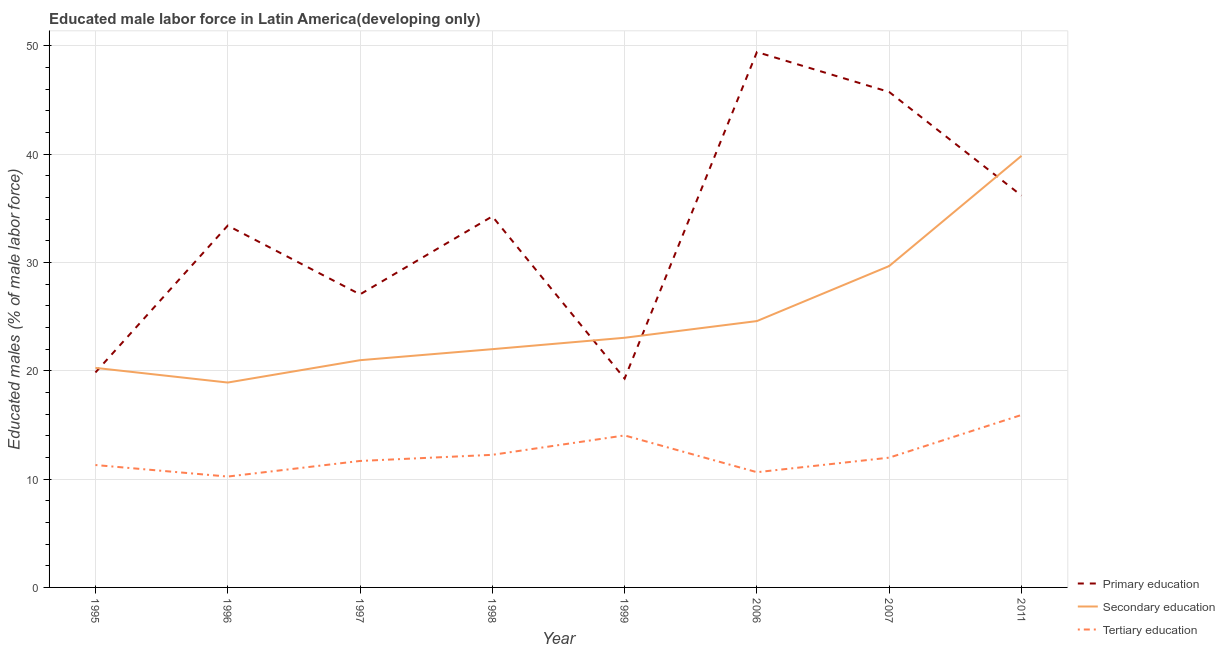How many different coloured lines are there?
Make the answer very short. 3. Does the line corresponding to percentage of male labor force who received secondary education intersect with the line corresponding to percentage of male labor force who received primary education?
Offer a terse response. Yes. What is the percentage of male labor force who received secondary education in 1998?
Offer a terse response. 21.99. Across all years, what is the maximum percentage of male labor force who received tertiary education?
Offer a terse response. 15.92. Across all years, what is the minimum percentage of male labor force who received tertiary education?
Give a very brief answer. 10.23. What is the total percentage of male labor force who received secondary education in the graph?
Make the answer very short. 199.3. What is the difference between the percentage of male labor force who received primary education in 1995 and that in 1997?
Keep it short and to the point. -7.21. What is the difference between the percentage of male labor force who received secondary education in 1999 and the percentage of male labor force who received primary education in 1996?
Your answer should be compact. -10.35. What is the average percentage of male labor force who received tertiary education per year?
Offer a very short reply. 12.25. In the year 2007, what is the difference between the percentage of male labor force who received secondary education and percentage of male labor force who received primary education?
Your response must be concise. -16.06. What is the ratio of the percentage of male labor force who received primary education in 1996 to that in 2011?
Give a very brief answer. 0.92. Is the difference between the percentage of male labor force who received primary education in 1997 and 2006 greater than the difference between the percentage of male labor force who received secondary education in 1997 and 2006?
Your response must be concise. No. What is the difference between the highest and the second highest percentage of male labor force who received primary education?
Your response must be concise. 3.69. What is the difference between the highest and the lowest percentage of male labor force who received secondary education?
Offer a terse response. 20.93. In how many years, is the percentage of male labor force who received primary education greater than the average percentage of male labor force who received primary education taken over all years?
Make the answer very short. 5. Is the percentage of male labor force who received secondary education strictly greater than the percentage of male labor force who received primary education over the years?
Ensure brevity in your answer.  No. Is the percentage of male labor force who received tertiary education strictly less than the percentage of male labor force who received secondary education over the years?
Make the answer very short. Yes. How many years are there in the graph?
Keep it short and to the point. 8. What is the difference between two consecutive major ticks on the Y-axis?
Provide a succinct answer. 10. Are the values on the major ticks of Y-axis written in scientific E-notation?
Provide a short and direct response. No. Does the graph contain any zero values?
Ensure brevity in your answer.  No. Does the graph contain grids?
Ensure brevity in your answer.  Yes. What is the title of the graph?
Make the answer very short. Educated male labor force in Latin America(developing only). Does "Interest" appear as one of the legend labels in the graph?
Provide a short and direct response. No. What is the label or title of the X-axis?
Give a very brief answer. Year. What is the label or title of the Y-axis?
Your response must be concise. Educated males (% of male labor force). What is the Educated males (% of male labor force) in Primary education in 1995?
Ensure brevity in your answer.  19.84. What is the Educated males (% of male labor force) of Secondary education in 1995?
Ensure brevity in your answer.  20.27. What is the Educated males (% of male labor force) of Tertiary education in 1995?
Give a very brief answer. 11.3. What is the Educated males (% of male labor force) in Primary education in 1996?
Ensure brevity in your answer.  33.4. What is the Educated males (% of male labor force) in Secondary education in 1996?
Your answer should be very brief. 18.91. What is the Educated males (% of male labor force) in Tertiary education in 1996?
Your answer should be very brief. 10.23. What is the Educated males (% of male labor force) in Primary education in 1997?
Offer a very short reply. 27.05. What is the Educated males (% of male labor force) in Secondary education in 1997?
Provide a succinct answer. 20.98. What is the Educated males (% of male labor force) of Tertiary education in 1997?
Make the answer very short. 11.67. What is the Educated males (% of male labor force) of Primary education in 1998?
Ensure brevity in your answer.  34.25. What is the Educated males (% of male labor force) of Secondary education in 1998?
Make the answer very short. 21.99. What is the Educated males (% of male labor force) in Tertiary education in 1998?
Give a very brief answer. 12.24. What is the Educated males (% of male labor force) in Primary education in 1999?
Your answer should be very brief. 19.28. What is the Educated males (% of male labor force) of Secondary education in 1999?
Keep it short and to the point. 23.05. What is the Educated males (% of male labor force) in Tertiary education in 1999?
Ensure brevity in your answer.  14.03. What is the Educated males (% of male labor force) in Primary education in 2006?
Your response must be concise. 49.42. What is the Educated males (% of male labor force) of Secondary education in 2006?
Give a very brief answer. 24.59. What is the Educated males (% of male labor force) in Tertiary education in 2006?
Make the answer very short. 10.64. What is the Educated males (% of male labor force) in Primary education in 2007?
Your response must be concise. 45.73. What is the Educated males (% of male labor force) of Secondary education in 2007?
Your response must be concise. 29.67. What is the Educated males (% of male labor force) in Tertiary education in 2007?
Keep it short and to the point. 11.98. What is the Educated males (% of male labor force) of Primary education in 2011?
Your answer should be very brief. 36.17. What is the Educated males (% of male labor force) of Secondary education in 2011?
Provide a short and direct response. 39.84. What is the Educated males (% of male labor force) in Tertiary education in 2011?
Keep it short and to the point. 15.92. Across all years, what is the maximum Educated males (% of male labor force) in Primary education?
Give a very brief answer. 49.42. Across all years, what is the maximum Educated males (% of male labor force) in Secondary education?
Offer a terse response. 39.84. Across all years, what is the maximum Educated males (% of male labor force) in Tertiary education?
Keep it short and to the point. 15.92. Across all years, what is the minimum Educated males (% of male labor force) in Primary education?
Your answer should be compact. 19.28. Across all years, what is the minimum Educated males (% of male labor force) in Secondary education?
Ensure brevity in your answer.  18.91. Across all years, what is the minimum Educated males (% of male labor force) of Tertiary education?
Provide a short and direct response. 10.23. What is the total Educated males (% of male labor force) in Primary education in the graph?
Give a very brief answer. 265.16. What is the total Educated males (% of male labor force) of Secondary education in the graph?
Provide a short and direct response. 199.3. What is the total Educated males (% of male labor force) of Tertiary education in the graph?
Provide a short and direct response. 98.02. What is the difference between the Educated males (% of male labor force) of Primary education in 1995 and that in 1996?
Offer a very short reply. -13.56. What is the difference between the Educated males (% of male labor force) of Secondary education in 1995 and that in 1996?
Make the answer very short. 1.35. What is the difference between the Educated males (% of male labor force) of Tertiary education in 1995 and that in 1996?
Give a very brief answer. 1.06. What is the difference between the Educated males (% of male labor force) of Primary education in 1995 and that in 1997?
Ensure brevity in your answer.  -7.21. What is the difference between the Educated males (% of male labor force) in Secondary education in 1995 and that in 1997?
Provide a short and direct response. -0.71. What is the difference between the Educated males (% of male labor force) in Tertiary education in 1995 and that in 1997?
Your answer should be very brief. -0.37. What is the difference between the Educated males (% of male labor force) in Primary education in 1995 and that in 1998?
Your response must be concise. -14.41. What is the difference between the Educated males (% of male labor force) of Secondary education in 1995 and that in 1998?
Make the answer very short. -1.73. What is the difference between the Educated males (% of male labor force) in Tertiary education in 1995 and that in 1998?
Make the answer very short. -0.94. What is the difference between the Educated males (% of male labor force) in Primary education in 1995 and that in 1999?
Ensure brevity in your answer.  0.57. What is the difference between the Educated males (% of male labor force) in Secondary education in 1995 and that in 1999?
Ensure brevity in your answer.  -2.78. What is the difference between the Educated males (% of male labor force) in Tertiary education in 1995 and that in 1999?
Make the answer very short. -2.73. What is the difference between the Educated males (% of male labor force) of Primary education in 1995 and that in 2006?
Make the answer very short. -29.58. What is the difference between the Educated males (% of male labor force) of Secondary education in 1995 and that in 2006?
Provide a short and direct response. -4.32. What is the difference between the Educated males (% of male labor force) of Tertiary education in 1995 and that in 2006?
Your response must be concise. 0.66. What is the difference between the Educated males (% of male labor force) of Primary education in 1995 and that in 2007?
Ensure brevity in your answer.  -25.89. What is the difference between the Educated males (% of male labor force) of Secondary education in 1995 and that in 2007?
Give a very brief answer. -9.4. What is the difference between the Educated males (% of male labor force) in Tertiary education in 1995 and that in 2007?
Provide a short and direct response. -0.68. What is the difference between the Educated males (% of male labor force) in Primary education in 1995 and that in 2011?
Provide a succinct answer. -16.33. What is the difference between the Educated males (% of male labor force) of Secondary education in 1995 and that in 2011?
Keep it short and to the point. -19.58. What is the difference between the Educated males (% of male labor force) in Tertiary education in 1995 and that in 2011?
Your answer should be very brief. -4.62. What is the difference between the Educated males (% of male labor force) in Primary education in 1996 and that in 1997?
Ensure brevity in your answer.  6.35. What is the difference between the Educated males (% of male labor force) of Secondary education in 1996 and that in 1997?
Your response must be concise. -2.06. What is the difference between the Educated males (% of male labor force) in Tertiary education in 1996 and that in 1997?
Ensure brevity in your answer.  -1.44. What is the difference between the Educated males (% of male labor force) in Primary education in 1996 and that in 1998?
Offer a very short reply. -0.85. What is the difference between the Educated males (% of male labor force) in Secondary education in 1996 and that in 1998?
Offer a very short reply. -3.08. What is the difference between the Educated males (% of male labor force) in Tertiary education in 1996 and that in 1998?
Your answer should be compact. -2.01. What is the difference between the Educated males (% of male labor force) of Primary education in 1996 and that in 1999?
Your response must be concise. 14.12. What is the difference between the Educated males (% of male labor force) of Secondary education in 1996 and that in 1999?
Offer a very short reply. -4.13. What is the difference between the Educated males (% of male labor force) in Tertiary education in 1996 and that in 1999?
Give a very brief answer. -3.8. What is the difference between the Educated males (% of male labor force) in Primary education in 1996 and that in 2006?
Offer a terse response. -16.02. What is the difference between the Educated males (% of male labor force) of Secondary education in 1996 and that in 2006?
Your response must be concise. -5.67. What is the difference between the Educated males (% of male labor force) of Tertiary education in 1996 and that in 2006?
Your answer should be compact. -0.4. What is the difference between the Educated males (% of male labor force) of Primary education in 1996 and that in 2007?
Your response must be concise. -12.33. What is the difference between the Educated males (% of male labor force) in Secondary education in 1996 and that in 2007?
Offer a terse response. -10.76. What is the difference between the Educated males (% of male labor force) in Tertiary education in 1996 and that in 2007?
Your response must be concise. -1.74. What is the difference between the Educated males (% of male labor force) of Primary education in 1996 and that in 2011?
Provide a short and direct response. -2.77. What is the difference between the Educated males (% of male labor force) in Secondary education in 1996 and that in 2011?
Offer a terse response. -20.93. What is the difference between the Educated males (% of male labor force) in Tertiary education in 1996 and that in 2011?
Offer a very short reply. -5.69. What is the difference between the Educated males (% of male labor force) in Primary education in 1997 and that in 1998?
Provide a short and direct response. -7.2. What is the difference between the Educated males (% of male labor force) in Secondary education in 1997 and that in 1998?
Provide a succinct answer. -1.02. What is the difference between the Educated males (% of male labor force) of Tertiary education in 1997 and that in 1998?
Provide a short and direct response. -0.57. What is the difference between the Educated males (% of male labor force) in Primary education in 1997 and that in 1999?
Provide a short and direct response. 7.77. What is the difference between the Educated males (% of male labor force) of Secondary education in 1997 and that in 1999?
Keep it short and to the point. -2.07. What is the difference between the Educated males (% of male labor force) in Tertiary education in 1997 and that in 1999?
Your response must be concise. -2.36. What is the difference between the Educated males (% of male labor force) in Primary education in 1997 and that in 2006?
Provide a succinct answer. -22.37. What is the difference between the Educated males (% of male labor force) of Secondary education in 1997 and that in 2006?
Your answer should be very brief. -3.61. What is the difference between the Educated males (% of male labor force) in Tertiary education in 1997 and that in 2006?
Keep it short and to the point. 1.04. What is the difference between the Educated males (% of male labor force) in Primary education in 1997 and that in 2007?
Offer a terse response. -18.68. What is the difference between the Educated males (% of male labor force) of Secondary education in 1997 and that in 2007?
Keep it short and to the point. -8.69. What is the difference between the Educated males (% of male labor force) of Tertiary education in 1997 and that in 2007?
Provide a short and direct response. -0.31. What is the difference between the Educated males (% of male labor force) of Primary education in 1997 and that in 2011?
Ensure brevity in your answer.  -9.12. What is the difference between the Educated males (% of male labor force) of Secondary education in 1997 and that in 2011?
Make the answer very short. -18.87. What is the difference between the Educated males (% of male labor force) of Tertiary education in 1997 and that in 2011?
Your response must be concise. -4.25. What is the difference between the Educated males (% of male labor force) of Primary education in 1998 and that in 1999?
Offer a very short reply. 14.97. What is the difference between the Educated males (% of male labor force) in Secondary education in 1998 and that in 1999?
Make the answer very short. -1.05. What is the difference between the Educated males (% of male labor force) in Tertiary education in 1998 and that in 1999?
Offer a very short reply. -1.79. What is the difference between the Educated males (% of male labor force) of Primary education in 1998 and that in 2006?
Keep it short and to the point. -15.17. What is the difference between the Educated males (% of male labor force) in Secondary education in 1998 and that in 2006?
Offer a very short reply. -2.59. What is the difference between the Educated males (% of male labor force) of Tertiary education in 1998 and that in 2006?
Offer a terse response. 1.6. What is the difference between the Educated males (% of male labor force) in Primary education in 1998 and that in 2007?
Provide a short and direct response. -11.48. What is the difference between the Educated males (% of male labor force) of Secondary education in 1998 and that in 2007?
Keep it short and to the point. -7.68. What is the difference between the Educated males (% of male labor force) in Tertiary education in 1998 and that in 2007?
Give a very brief answer. 0.26. What is the difference between the Educated males (% of male labor force) of Primary education in 1998 and that in 2011?
Keep it short and to the point. -1.92. What is the difference between the Educated males (% of male labor force) in Secondary education in 1998 and that in 2011?
Your answer should be very brief. -17.85. What is the difference between the Educated males (% of male labor force) of Tertiary education in 1998 and that in 2011?
Your response must be concise. -3.68. What is the difference between the Educated males (% of male labor force) in Primary education in 1999 and that in 2006?
Offer a very short reply. -30.14. What is the difference between the Educated males (% of male labor force) in Secondary education in 1999 and that in 2006?
Offer a terse response. -1.54. What is the difference between the Educated males (% of male labor force) of Tertiary education in 1999 and that in 2006?
Give a very brief answer. 3.39. What is the difference between the Educated males (% of male labor force) in Primary education in 1999 and that in 2007?
Provide a succinct answer. -26.46. What is the difference between the Educated males (% of male labor force) of Secondary education in 1999 and that in 2007?
Your response must be concise. -6.62. What is the difference between the Educated males (% of male labor force) of Tertiary education in 1999 and that in 2007?
Offer a very short reply. 2.05. What is the difference between the Educated males (% of male labor force) of Primary education in 1999 and that in 2011?
Give a very brief answer. -16.89. What is the difference between the Educated males (% of male labor force) in Secondary education in 1999 and that in 2011?
Offer a very short reply. -16.8. What is the difference between the Educated males (% of male labor force) in Tertiary education in 1999 and that in 2011?
Provide a succinct answer. -1.89. What is the difference between the Educated males (% of male labor force) of Primary education in 2006 and that in 2007?
Offer a very short reply. 3.69. What is the difference between the Educated males (% of male labor force) of Secondary education in 2006 and that in 2007?
Keep it short and to the point. -5.08. What is the difference between the Educated males (% of male labor force) of Tertiary education in 2006 and that in 2007?
Provide a succinct answer. -1.34. What is the difference between the Educated males (% of male labor force) of Primary education in 2006 and that in 2011?
Ensure brevity in your answer.  13.25. What is the difference between the Educated males (% of male labor force) of Secondary education in 2006 and that in 2011?
Keep it short and to the point. -15.25. What is the difference between the Educated males (% of male labor force) in Tertiary education in 2006 and that in 2011?
Offer a terse response. -5.28. What is the difference between the Educated males (% of male labor force) in Primary education in 2007 and that in 2011?
Ensure brevity in your answer.  9.56. What is the difference between the Educated males (% of male labor force) of Secondary education in 2007 and that in 2011?
Keep it short and to the point. -10.17. What is the difference between the Educated males (% of male labor force) of Tertiary education in 2007 and that in 2011?
Ensure brevity in your answer.  -3.94. What is the difference between the Educated males (% of male labor force) of Primary education in 1995 and the Educated males (% of male labor force) of Secondary education in 1996?
Make the answer very short. 0.93. What is the difference between the Educated males (% of male labor force) of Primary education in 1995 and the Educated males (% of male labor force) of Tertiary education in 1996?
Give a very brief answer. 9.61. What is the difference between the Educated males (% of male labor force) of Secondary education in 1995 and the Educated males (% of male labor force) of Tertiary education in 1996?
Make the answer very short. 10.03. What is the difference between the Educated males (% of male labor force) of Primary education in 1995 and the Educated males (% of male labor force) of Secondary education in 1997?
Keep it short and to the point. -1.13. What is the difference between the Educated males (% of male labor force) in Primary education in 1995 and the Educated males (% of male labor force) in Tertiary education in 1997?
Keep it short and to the point. 8.17. What is the difference between the Educated males (% of male labor force) in Secondary education in 1995 and the Educated males (% of male labor force) in Tertiary education in 1997?
Your answer should be compact. 8.59. What is the difference between the Educated males (% of male labor force) in Primary education in 1995 and the Educated males (% of male labor force) in Secondary education in 1998?
Provide a short and direct response. -2.15. What is the difference between the Educated males (% of male labor force) of Primary education in 1995 and the Educated males (% of male labor force) of Tertiary education in 1998?
Offer a very short reply. 7.6. What is the difference between the Educated males (% of male labor force) of Secondary education in 1995 and the Educated males (% of male labor force) of Tertiary education in 1998?
Your answer should be very brief. 8.03. What is the difference between the Educated males (% of male labor force) of Primary education in 1995 and the Educated males (% of male labor force) of Secondary education in 1999?
Keep it short and to the point. -3.2. What is the difference between the Educated males (% of male labor force) of Primary education in 1995 and the Educated males (% of male labor force) of Tertiary education in 1999?
Give a very brief answer. 5.81. What is the difference between the Educated males (% of male labor force) of Secondary education in 1995 and the Educated males (% of male labor force) of Tertiary education in 1999?
Your response must be concise. 6.24. What is the difference between the Educated males (% of male labor force) in Primary education in 1995 and the Educated males (% of male labor force) in Secondary education in 2006?
Provide a short and direct response. -4.74. What is the difference between the Educated males (% of male labor force) of Primary education in 1995 and the Educated males (% of male labor force) of Tertiary education in 2006?
Your response must be concise. 9.21. What is the difference between the Educated males (% of male labor force) in Secondary education in 1995 and the Educated males (% of male labor force) in Tertiary education in 2006?
Your answer should be compact. 9.63. What is the difference between the Educated males (% of male labor force) of Primary education in 1995 and the Educated males (% of male labor force) of Secondary education in 2007?
Ensure brevity in your answer.  -9.82. What is the difference between the Educated males (% of male labor force) in Primary education in 1995 and the Educated males (% of male labor force) in Tertiary education in 2007?
Your answer should be very brief. 7.87. What is the difference between the Educated males (% of male labor force) in Secondary education in 1995 and the Educated males (% of male labor force) in Tertiary education in 2007?
Your response must be concise. 8.29. What is the difference between the Educated males (% of male labor force) of Primary education in 1995 and the Educated males (% of male labor force) of Secondary education in 2011?
Keep it short and to the point. -20. What is the difference between the Educated males (% of male labor force) in Primary education in 1995 and the Educated males (% of male labor force) in Tertiary education in 2011?
Provide a short and direct response. 3.92. What is the difference between the Educated males (% of male labor force) in Secondary education in 1995 and the Educated males (% of male labor force) in Tertiary education in 2011?
Make the answer very short. 4.35. What is the difference between the Educated males (% of male labor force) in Primary education in 1996 and the Educated males (% of male labor force) in Secondary education in 1997?
Keep it short and to the point. 12.42. What is the difference between the Educated males (% of male labor force) in Primary education in 1996 and the Educated males (% of male labor force) in Tertiary education in 1997?
Offer a terse response. 21.73. What is the difference between the Educated males (% of male labor force) in Secondary education in 1996 and the Educated males (% of male labor force) in Tertiary education in 1997?
Provide a short and direct response. 7.24. What is the difference between the Educated males (% of male labor force) of Primary education in 1996 and the Educated males (% of male labor force) of Secondary education in 1998?
Offer a terse response. 11.41. What is the difference between the Educated males (% of male labor force) in Primary education in 1996 and the Educated males (% of male labor force) in Tertiary education in 1998?
Offer a terse response. 21.16. What is the difference between the Educated males (% of male labor force) in Secondary education in 1996 and the Educated males (% of male labor force) in Tertiary education in 1998?
Offer a very short reply. 6.67. What is the difference between the Educated males (% of male labor force) in Primary education in 1996 and the Educated males (% of male labor force) in Secondary education in 1999?
Your answer should be compact. 10.35. What is the difference between the Educated males (% of male labor force) of Primary education in 1996 and the Educated males (% of male labor force) of Tertiary education in 1999?
Give a very brief answer. 19.37. What is the difference between the Educated males (% of male labor force) in Secondary education in 1996 and the Educated males (% of male labor force) in Tertiary education in 1999?
Your answer should be very brief. 4.88. What is the difference between the Educated males (% of male labor force) of Primary education in 1996 and the Educated males (% of male labor force) of Secondary education in 2006?
Your response must be concise. 8.81. What is the difference between the Educated males (% of male labor force) of Primary education in 1996 and the Educated males (% of male labor force) of Tertiary education in 2006?
Your answer should be compact. 22.76. What is the difference between the Educated males (% of male labor force) in Secondary education in 1996 and the Educated males (% of male labor force) in Tertiary education in 2006?
Offer a very short reply. 8.28. What is the difference between the Educated males (% of male labor force) of Primary education in 1996 and the Educated males (% of male labor force) of Secondary education in 2007?
Your answer should be very brief. 3.73. What is the difference between the Educated males (% of male labor force) in Primary education in 1996 and the Educated males (% of male labor force) in Tertiary education in 2007?
Your answer should be very brief. 21.42. What is the difference between the Educated males (% of male labor force) in Secondary education in 1996 and the Educated males (% of male labor force) in Tertiary education in 2007?
Your response must be concise. 6.93. What is the difference between the Educated males (% of male labor force) in Primary education in 1996 and the Educated males (% of male labor force) in Secondary education in 2011?
Ensure brevity in your answer.  -6.44. What is the difference between the Educated males (% of male labor force) of Primary education in 1996 and the Educated males (% of male labor force) of Tertiary education in 2011?
Keep it short and to the point. 17.48. What is the difference between the Educated males (% of male labor force) in Secondary education in 1996 and the Educated males (% of male labor force) in Tertiary education in 2011?
Offer a terse response. 2.99. What is the difference between the Educated males (% of male labor force) of Primary education in 1997 and the Educated males (% of male labor force) of Secondary education in 1998?
Your answer should be very brief. 5.06. What is the difference between the Educated males (% of male labor force) in Primary education in 1997 and the Educated males (% of male labor force) in Tertiary education in 1998?
Your answer should be very brief. 14.81. What is the difference between the Educated males (% of male labor force) of Secondary education in 1997 and the Educated males (% of male labor force) of Tertiary education in 1998?
Give a very brief answer. 8.74. What is the difference between the Educated males (% of male labor force) of Primary education in 1997 and the Educated males (% of male labor force) of Secondary education in 1999?
Give a very brief answer. 4.01. What is the difference between the Educated males (% of male labor force) in Primary education in 1997 and the Educated males (% of male labor force) in Tertiary education in 1999?
Your response must be concise. 13.02. What is the difference between the Educated males (% of male labor force) of Secondary education in 1997 and the Educated males (% of male labor force) of Tertiary education in 1999?
Give a very brief answer. 6.95. What is the difference between the Educated males (% of male labor force) of Primary education in 1997 and the Educated males (% of male labor force) of Secondary education in 2006?
Your response must be concise. 2.46. What is the difference between the Educated males (% of male labor force) of Primary education in 1997 and the Educated males (% of male labor force) of Tertiary education in 2006?
Offer a terse response. 16.42. What is the difference between the Educated males (% of male labor force) of Secondary education in 1997 and the Educated males (% of male labor force) of Tertiary education in 2006?
Provide a succinct answer. 10.34. What is the difference between the Educated males (% of male labor force) of Primary education in 1997 and the Educated males (% of male labor force) of Secondary education in 2007?
Offer a terse response. -2.62. What is the difference between the Educated males (% of male labor force) in Primary education in 1997 and the Educated males (% of male labor force) in Tertiary education in 2007?
Your response must be concise. 15.07. What is the difference between the Educated males (% of male labor force) of Secondary education in 1997 and the Educated males (% of male labor force) of Tertiary education in 2007?
Your response must be concise. 9. What is the difference between the Educated males (% of male labor force) in Primary education in 1997 and the Educated males (% of male labor force) in Secondary education in 2011?
Provide a succinct answer. -12.79. What is the difference between the Educated males (% of male labor force) of Primary education in 1997 and the Educated males (% of male labor force) of Tertiary education in 2011?
Your response must be concise. 11.13. What is the difference between the Educated males (% of male labor force) in Secondary education in 1997 and the Educated males (% of male labor force) in Tertiary education in 2011?
Your answer should be very brief. 5.05. What is the difference between the Educated males (% of male labor force) in Primary education in 1998 and the Educated males (% of male labor force) in Secondary education in 1999?
Ensure brevity in your answer.  11.21. What is the difference between the Educated males (% of male labor force) in Primary education in 1998 and the Educated males (% of male labor force) in Tertiary education in 1999?
Ensure brevity in your answer.  20.22. What is the difference between the Educated males (% of male labor force) in Secondary education in 1998 and the Educated males (% of male labor force) in Tertiary education in 1999?
Keep it short and to the point. 7.96. What is the difference between the Educated males (% of male labor force) of Primary education in 1998 and the Educated males (% of male labor force) of Secondary education in 2006?
Provide a short and direct response. 9.67. What is the difference between the Educated males (% of male labor force) of Primary education in 1998 and the Educated males (% of male labor force) of Tertiary education in 2006?
Ensure brevity in your answer.  23.62. What is the difference between the Educated males (% of male labor force) in Secondary education in 1998 and the Educated males (% of male labor force) in Tertiary education in 2006?
Give a very brief answer. 11.36. What is the difference between the Educated males (% of male labor force) of Primary education in 1998 and the Educated males (% of male labor force) of Secondary education in 2007?
Your response must be concise. 4.58. What is the difference between the Educated males (% of male labor force) of Primary education in 1998 and the Educated males (% of male labor force) of Tertiary education in 2007?
Provide a succinct answer. 22.27. What is the difference between the Educated males (% of male labor force) in Secondary education in 1998 and the Educated males (% of male labor force) in Tertiary education in 2007?
Make the answer very short. 10.01. What is the difference between the Educated males (% of male labor force) in Primary education in 1998 and the Educated males (% of male labor force) in Secondary education in 2011?
Your response must be concise. -5.59. What is the difference between the Educated males (% of male labor force) of Primary education in 1998 and the Educated males (% of male labor force) of Tertiary education in 2011?
Give a very brief answer. 18.33. What is the difference between the Educated males (% of male labor force) of Secondary education in 1998 and the Educated males (% of male labor force) of Tertiary education in 2011?
Your response must be concise. 6.07. What is the difference between the Educated males (% of male labor force) in Primary education in 1999 and the Educated males (% of male labor force) in Secondary education in 2006?
Provide a succinct answer. -5.31. What is the difference between the Educated males (% of male labor force) in Primary education in 1999 and the Educated males (% of male labor force) in Tertiary education in 2006?
Your response must be concise. 8.64. What is the difference between the Educated males (% of male labor force) of Secondary education in 1999 and the Educated males (% of male labor force) of Tertiary education in 2006?
Offer a very short reply. 12.41. What is the difference between the Educated males (% of male labor force) in Primary education in 1999 and the Educated males (% of male labor force) in Secondary education in 2007?
Your response must be concise. -10.39. What is the difference between the Educated males (% of male labor force) in Primary education in 1999 and the Educated males (% of male labor force) in Tertiary education in 2007?
Ensure brevity in your answer.  7.3. What is the difference between the Educated males (% of male labor force) in Secondary education in 1999 and the Educated males (% of male labor force) in Tertiary education in 2007?
Provide a short and direct response. 11.07. What is the difference between the Educated males (% of male labor force) in Primary education in 1999 and the Educated males (% of male labor force) in Secondary education in 2011?
Provide a succinct answer. -20.56. What is the difference between the Educated males (% of male labor force) in Primary education in 1999 and the Educated males (% of male labor force) in Tertiary education in 2011?
Offer a very short reply. 3.36. What is the difference between the Educated males (% of male labor force) in Secondary education in 1999 and the Educated males (% of male labor force) in Tertiary education in 2011?
Ensure brevity in your answer.  7.13. What is the difference between the Educated males (% of male labor force) in Primary education in 2006 and the Educated males (% of male labor force) in Secondary education in 2007?
Your response must be concise. 19.75. What is the difference between the Educated males (% of male labor force) in Primary education in 2006 and the Educated males (% of male labor force) in Tertiary education in 2007?
Provide a short and direct response. 37.44. What is the difference between the Educated males (% of male labor force) in Secondary education in 2006 and the Educated males (% of male labor force) in Tertiary education in 2007?
Your answer should be compact. 12.61. What is the difference between the Educated males (% of male labor force) in Primary education in 2006 and the Educated males (% of male labor force) in Secondary education in 2011?
Your response must be concise. 9.58. What is the difference between the Educated males (% of male labor force) of Primary education in 2006 and the Educated males (% of male labor force) of Tertiary education in 2011?
Provide a succinct answer. 33.5. What is the difference between the Educated males (% of male labor force) of Secondary education in 2006 and the Educated males (% of male labor force) of Tertiary education in 2011?
Keep it short and to the point. 8.67. What is the difference between the Educated males (% of male labor force) of Primary education in 2007 and the Educated males (% of male labor force) of Secondary education in 2011?
Offer a very short reply. 5.89. What is the difference between the Educated males (% of male labor force) in Primary education in 2007 and the Educated males (% of male labor force) in Tertiary education in 2011?
Provide a succinct answer. 29.81. What is the difference between the Educated males (% of male labor force) of Secondary education in 2007 and the Educated males (% of male labor force) of Tertiary education in 2011?
Your answer should be compact. 13.75. What is the average Educated males (% of male labor force) in Primary education per year?
Ensure brevity in your answer.  33.14. What is the average Educated males (% of male labor force) of Secondary education per year?
Provide a short and direct response. 24.91. What is the average Educated males (% of male labor force) in Tertiary education per year?
Give a very brief answer. 12.25. In the year 1995, what is the difference between the Educated males (% of male labor force) of Primary education and Educated males (% of male labor force) of Secondary education?
Keep it short and to the point. -0.42. In the year 1995, what is the difference between the Educated males (% of male labor force) in Primary education and Educated males (% of male labor force) in Tertiary education?
Give a very brief answer. 8.55. In the year 1995, what is the difference between the Educated males (% of male labor force) of Secondary education and Educated males (% of male labor force) of Tertiary education?
Keep it short and to the point. 8.97. In the year 1996, what is the difference between the Educated males (% of male labor force) of Primary education and Educated males (% of male labor force) of Secondary education?
Give a very brief answer. 14.49. In the year 1996, what is the difference between the Educated males (% of male labor force) of Primary education and Educated males (% of male labor force) of Tertiary education?
Your answer should be compact. 23.17. In the year 1996, what is the difference between the Educated males (% of male labor force) of Secondary education and Educated males (% of male labor force) of Tertiary education?
Provide a short and direct response. 8.68. In the year 1997, what is the difference between the Educated males (% of male labor force) in Primary education and Educated males (% of male labor force) in Secondary education?
Offer a very short reply. 6.08. In the year 1997, what is the difference between the Educated males (% of male labor force) in Primary education and Educated males (% of male labor force) in Tertiary education?
Your response must be concise. 15.38. In the year 1997, what is the difference between the Educated males (% of male labor force) in Secondary education and Educated males (% of male labor force) in Tertiary education?
Make the answer very short. 9.3. In the year 1998, what is the difference between the Educated males (% of male labor force) of Primary education and Educated males (% of male labor force) of Secondary education?
Offer a very short reply. 12.26. In the year 1998, what is the difference between the Educated males (% of male labor force) in Primary education and Educated males (% of male labor force) in Tertiary education?
Offer a terse response. 22.01. In the year 1998, what is the difference between the Educated males (% of male labor force) of Secondary education and Educated males (% of male labor force) of Tertiary education?
Offer a terse response. 9.75. In the year 1999, what is the difference between the Educated males (% of male labor force) in Primary education and Educated males (% of male labor force) in Secondary education?
Your answer should be very brief. -3.77. In the year 1999, what is the difference between the Educated males (% of male labor force) of Primary education and Educated males (% of male labor force) of Tertiary education?
Provide a succinct answer. 5.25. In the year 1999, what is the difference between the Educated males (% of male labor force) in Secondary education and Educated males (% of male labor force) in Tertiary education?
Provide a short and direct response. 9.02. In the year 2006, what is the difference between the Educated males (% of male labor force) in Primary education and Educated males (% of male labor force) in Secondary education?
Your answer should be compact. 24.83. In the year 2006, what is the difference between the Educated males (% of male labor force) of Primary education and Educated males (% of male labor force) of Tertiary education?
Your answer should be compact. 38.79. In the year 2006, what is the difference between the Educated males (% of male labor force) of Secondary education and Educated males (% of male labor force) of Tertiary education?
Your answer should be very brief. 13.95. In the year 2007, what is the difference between the Educated males (% of male labor force) of Primary education and Educated males (% of male labor force) of Secondary education?
Provide a short and direct response. 16.06. In the year 2007, what is the difference between the Educated males (% of male labor force) in Primary education and Educated males (% of male labor force) in Tertiary education?
Keep it short and to the point. 33.75. In the year 2007, what is the difference between the Educated males (% of male labor force) of Secondary education and Educated males (% of male labor force) of Tertiary education?
Provide a short and direct response. 17.69. In the year 2011, what is the difference between the Educated males (% of male labor force) of Primary education and Educated males (% of male labor force) of Secondary education?
Offer a very short reply. -3.67. In the year 2011, what is the difference between the Educated males (% of male labor force) of Primary education and Educated males (% of male labor force) of Tertiary education?
Your response must be concise. 20.25. In the year 2011, what is the difference between the Educated males (% of male labor force) in Secondary education and Educated males (% of male labor force) in Tertiary education?
Keep it short and to the point. 23.92. What is the ratio of the Educated males (% of male labor force) of Primary education in 1995 to that in 1996?
Your answer should be compact. 0.59. What is the ratio of the Educated males (% of male labor force) of Secondary education in 1995 to that in 1996?
Your response must be concise. 1.07. What is the ratio of the Educated males (% of male labor force) in Tertiary education in 1995 to that in 1996?
Your answer should be compact. 1.1. What is the ratio of the Educated males (% of male labor force) of Primary education in 1995 to that in 1997?
Your response must be concise. 0.73. What is the ratio of the Educated males (% of male labor force) of Secondary education in 1995 to that in 1997?
Offer a very short reply. 0.97. What is the ratio of the Educated males (% of male labor force) of Tertiary education in 1995 to that in 1997?
Provide a short and direct response. 0.97. What is the ratio of the Educated males (% of male labor force) in Primary education in 1995 to that in 1998?
Your response must be concise. 0.58. What is the ratio of the Educated males (% of male labor force) in Secondary education in 1995 to that in 1998?
Provide a succinct answer. 0.92. What is the ratio of the Educated males (% of male labor force) of Tertiary education in 1995 to that in 1998?
Keep it short and to the point. 0.92. What is the ratio of the Educated males (% of male labor force) of Primary education in 1995 to that in 1999?
Your answer should be very brief. 1.03. What is the ratio of the Educated males (% of male labor force) in Secondary education in 1995 to that in 1999?
Make the answer very short. 0.88. What is the ratio of the Educated males (% of male labor force) in Tertiary education in 1995 to that in 1999?
Your answer should be very brief. 0.81. What is the ratio of the Educated males (% of male labor force) in Primary education in 1995 to that in 2006?
Ensure brevity in your answer.  0.4. What is the ratio of the Educated males (% of male labor force) of Secondary education in 1995 to that in 2006?
Your answer should be very brief. 0.82. What is the ratio of the Educated males (% of male labor force) in Tertiary education in 1995 to that in 2006?
Your response must be concise. 1.06. What is the ratio of the Educated males (% of male labor force) of Primary education in 1995 to that in 2007?
Make the answer very short. 0.43. What is the ratio of the Educated males (% of male labor force) of Secondary education in 1995 to that in 2007?
Offer a terse response. 0.68. What is the ratio of the Educated males (% of male labor force) in Tertiary education in 1995 to that in 2007?
Your answer should be compact. 0.94. What is the ratio of the Educated males (% of male labor force) of Primary education in 1995 to that in 2011?
Make the answer very short. 0.55. What is the ratio of the Educated males (% of male labor force) in Secondary education in 1995 to that in 2011?
Ensure brevity in your answer.  0.51. What is the ratio of the Educated males (% of male labor force) of Tertiary education in 1995 to that in 2011?
Give a very brief answer. 0.71. What is the ratio of the Educated males (% of male labor force) of Primary education in 1996 to that in 1997?
Make the answer very short. 1.23. What is the ratio of the Educated males (% of male labor force) of Secondary education in 1996 to that in 1997?
Your response must be concise. 0.9. What is the ratio of the Educated males (% of male labor force) of Tertiary education in 1996 to that in 1997?
Give a very brief answer. 0.88. What is the ratio of the Educated males (% of male labor force) of Primary education in 1996 to that in 1998?
Your response must be concise. 0.98. What is the ratio of the Educated males (% of male labor force) in Secondary education in 1996 to that in 1998?
Your answer should be very brief. 0.86. What is the ratio of the Educated males (% of male labor force) in Tertiary education in 1996 to that in 1998?
Your response must be concise. 0.84. What is the ratio of the Educated males (% of male labor force) in Primary education in 1996 to that in 1999?
Provide a short and direct response. 1.73. What is the ratio of the Educated males (% of male labor force) in Secondary education in 1996 to that in 1999?
Give a very brief answer. 0.82. What is the ratio of the Educated males (% of male labor force) of Tertiary education in 1996 to that in 1999?
Provide a short and direct response. 0.73. What is the ratio of the Educated males (% of male labor force) in Primary education in 1996 to that in 2006?
Provide a short and direct response. 0.68. What is the ratio of the Educated males (% of male labor force) in Secondary education in 1996 to that in 2006?
Offer a very short reply. 0.77. What is the ratio of the Educated males (% of male labor force) in Tertiary education in 1996 to that in 2006?
Your answer should be compact. 0.96. What is the ratio of the Educated males (% of male labor force) in Primary education in 1996 to that in 2007?
Provide a succinct answer. 0.73. What is the ratio of the Educated males (% of male labor force) of Secondary education in 1996 to that in 2007?
Keep it short and to the point. 0.64. What is the ratio of the Educated males (% of male labor force) in Tertiary education in 1996 to that in 2007?
Your answer should be very brief. 0.85. What is the ratio of the Educated males (% of male labor force) in Primary education in 1996 to that in 2011?
Your answer should be compact. 0.92. What is the ratio of the Educated males (% of male labor force) in Secondary education in 1996 to that in 2011?
Offer a very short reply. 0.47. What is the ratio of the Educated males (% of male labor force) in Tertiary education in 1996 to that in 2011?
Ensure brevity in your answer.  0.64. What is the ratio of the Educated males (% of male labor force) of Primary education in 1997 to that in 1998?
Provide a short and direct response. 0.79. What is the ratio of the Educated males (% of male labor force) in Secondary education in 1997 to that in 1998?
Provide a short and direct response. 0.95. What is the ratio of the Educated males (% of male labor force) in Tertiary education in 1997 to that in 1998?
Ensure brevity in your answer.  0.95. What is the ratio of the Educated males (% of male labor force) in Primary education in 1997 to that in 1999?
Offer a terse response. 1.4. What is the ratio of the Educated males (% of male labor force) in Secondary education in 1997 to that in 1999?
Your answer should be very brief. 0.91. What is the ratio of the Educated males (% of male labor force) of Tertiary education in 1997 to that in 1999?
Provide a short and direct response. 0.83. What is the ratio of the Educated males (% of male labor force) in Primary education in 1997 to that in 2006?
Your answer should be compact. 0.55. What is the ratio of the Educated males (% of male labor force) of Secondary education in 1997 to that in 2006?
Offer a terse response. 0.85. What is the ratio of the Educated males (% of male labor force) in Tertiary education in 1997 to that in 2006?
Give a very brief answer. 1.1. What is the ratio of the Educated males (% of male labor force) in Primary education in 1997 to that in 2007?
Make the answer very short. 0.59. What is the ratio of the Educated males (% of male labor force) of Secondary education in 1997 to that in 2007?
Ensure brevity in your answer.  0.71. What is the ratio of the Educated males (% of male labor force) of Tertiary education in 1997 to that in 2007?
Provide a short and direct response. 0.97. What is the ratio of the Educated males (% of male labor force) in Primary education in 1997 to that in 2011?
Provide a succinct answer. 0.75. What is the ratio of the Educated males (% of male labor force) in Secondary education in 1997 to that in 2011?
Provide a succinct answer. 0.53. What is the ratio of the Educated males (% of male labor force) in Tertiary education in 1997 to that in 2011?
Your response must be concise. 0.73. What is the ratio of the Educated males (% of male labor force) of Primary education in 1998 to that in 1999?
Your answer should be very brief. 1.78. What is the ratio of the Educated males (% of male labor force) in Secondary education in 1998 to that in 1999?
Ensure brevity in your answer.  0.95. What is the ratio of the Educated males (% of male labor force) in Tertiary education in 1998 to that in 1999?
Your answer should be compact. 0.87. What is the ratio of the Educated males (% of male labor force) of Primary education in 1998 to that in 2006?
Provide a short and direct response. 0.69. What is the ratio of the Educated males (% of male labor force) of Secondary education in 1998 to that in 2006?
Offer a very short reply. 0.89. What is the ratio of the Educated males (% of male labor force) of Tertiary education in 1998 to that in 2006?
Your answer should be very brief. 1.15. What is the ratio of the Educated males (% of male labor force) of Primary education in 1998 to that in 2007?
Offer a terse response. 0.75. What is the ratio of the Educated males (% of male labor force) of Secondary education in 1998 to that in 2007?
Your answer should be very brief. 0.74. What is the ratio of the Educated males (% of male labor force) of Tertiary education in 1998 to that in 2007?
Keep it short and to the point. 1.02. What is the ratio of the Educated males (% of male labor force) of Primary education in 1998 to that in 2011?
Ensure brevity in your answer.  0.95. What is the ratio of the Educated males (% of male labor force) of Secondary education in 1998 to that in 2011?
Ensure brevity in your answer.  0.55. What is the ratio of the Educated males (% of male labor force) of Tertiary education in 1998 to that in 2011?
Offer a terse response. 0.77. What is the ratio of the Educated males (% of male labor force) in Primary education in 1999 to that in 2006?
Make the answer very short. 0.39. What is the ratio of the Educated males (% of male labor force) in Secondary education in 1999 to that in 2006?
Your answer should be very brief. 0.94. What is the ratio of the Educated males (% of male labor force) in Tertiary education in 1999 to that in 2006?
Your answer should be very brief. 1.32. What is the ratio of the Educated males (% of male labor force) of Primary education in 1999 to that in 2007?
Keep it short and to the point. 0.42. What is the ratio of the Educated males (% of male labor force) in Secondary education in 1999 to that in 2007?
Provide a short and direct response. 0.78. What is the ratio of the Educated males (% of male labor force) in Tertiary education in 1999 to that in 2007?
Provide a succinct answer. 1.17. What is the ratio of the Educated males (% of male labor force) of Primary education in 1999 to that in 2011?
Offer a terse response. 0.53. What is the ratio of the Educated males (% of male labor force) in Secondary education in 1999 to that in 2011?
Your answer should be compact. 0.58. What is the ratio of the Educated males (% of male labor force) in Tertiary education in 1999 to that in 2011?
Your response must be concise. 0.88. What is the ratio of the Educated males (% of male labor force) of Primary education in 2006 to that in 2007?
Ensure brevity in your answer.  1.08. What is the ratio of the Educated males (% of male labor force) of Secondary education in 2006 to that in 2007?
Your answer should be compact. 0.83. What is the ratio of the Educated males (% of male labor force) in Tertiary education in 2006 to that in 2007?
Your answer should be very brief. 0.89. What is the ratio of the Educated males (% of male labor force) in Primary education in 2006 to that in 2011?
Your response must be concise. 1.37. What is the ratio of the Educated males (% of male labor force) of Secondary education in 2006 to that in 2011?
Your response must be concise. 0.62. What is the ratio of the Educated males (% of male labor force) of Tertiary education in 2006 to that in 2011?
Offer a very short reply. 0.67. What is the ratio of the Educated males (% of male labor force) in Primary education in 2007 to that in 2011?
Ensure brevity in your answer.  1.26. What is the ratio of the Educated males (% of male labor force) in Secondary education in 2007 to that in 2011?
Provide a succinct answer. 0.74. What is the ratio of the Educated males (% of male labor force) of Tertiary education in 2007 to that in 2011?
Your answer should be compact. 0.75. What is the difference between the highest and the second highest Educated males (% of male labor force) of Primary education?
Your response must be concise. 3.69. What is the difference between the highest and the second highest Educated males (% of male labor force) in Secondary education?
Your answer should be compact. 10.17. What is the difference between the highest and the second highest Educated males (% of male labor force) in Tertiary education?
Your answer should be very brief. 1.89. What is the difference between the highest and the lowest Educated males (% of male labor force) of Primary education?
Provide a succinct answer. 30.14. What is the difference between the highest and the lowest Educated males (% of male labor force) in Secondary education?
Ensure brevity in your answer.  20.93. What is the difference between the highest and the lowest Educated males (% of male labor force) in Tertiary education?
Provide a succinct answer. 5.69. 